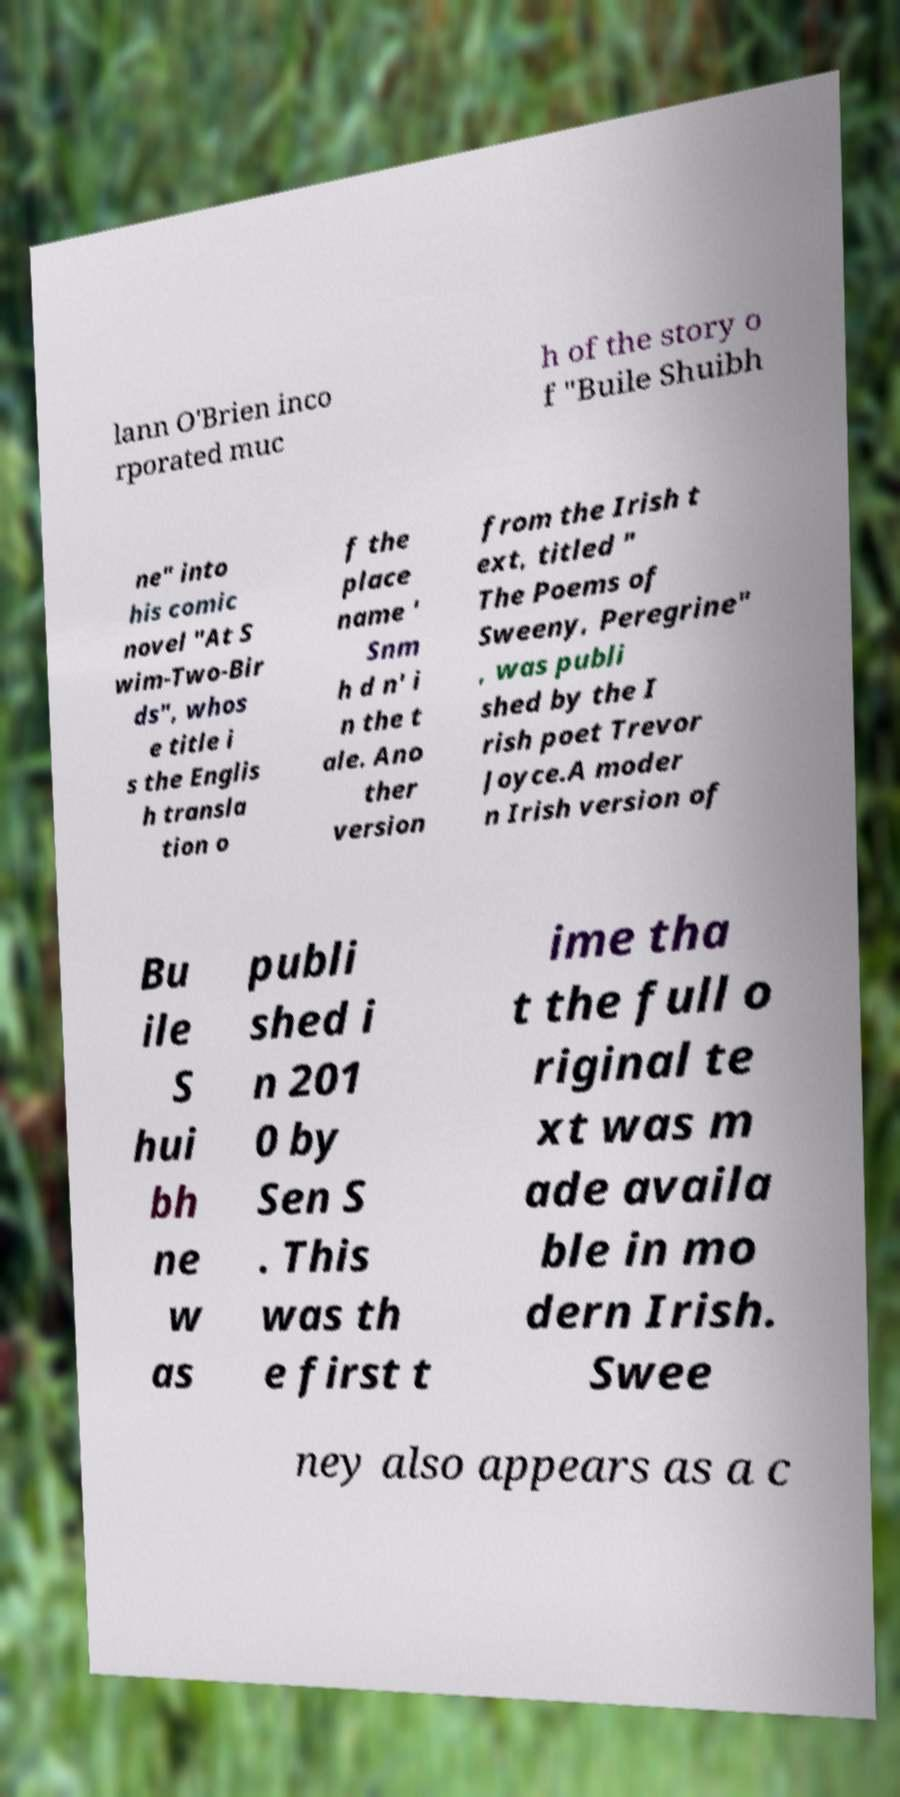For documentation purposes, I need the text within this image transcribed. Could you provide that? lann O'Brien inco rporated muc h of the story o f "Buile Shuibh ne" into his comic novel "At S wim-Two-Bir ds", whos e title i s the Englis h transla tion o f the place name ' Snm h d n' i n the t ale. Ano ther version from the Irish t ext, titled " The Poems of Sweeny, Peregrine" , was publi shed by the I rish poet Trevor Joyce.A moder n Irish version of Bu ile S hui bh ne w as publi shed i n 201 0 by Sen S . This was th e first t ime tha t the full o riginal te xt was m ade availa ble in mo dern Irish. Swee ney also appears as a c 